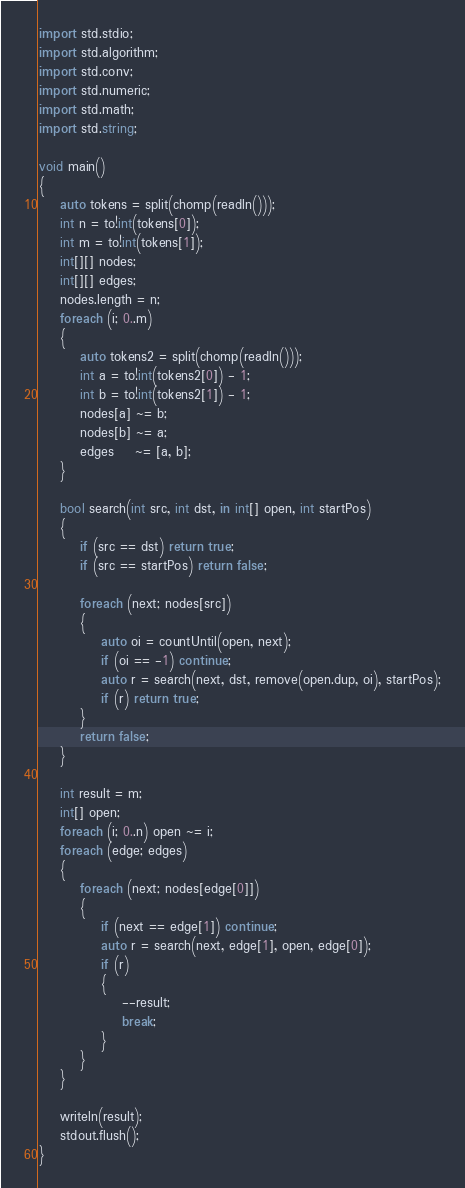<code> <loc_0><loc_0><loc_500><loc_500><_D_>import std.stdio;
import std.algorithm;
import std.conv;
import std.numeric;
import std.math;
import std.string;

void main()
{
	auto tokens = split(chomp(readln()));
	int n = to!int(tokens[0]);
	int m = to!int(tokens[1]);
	int[][] nodes;
	int[][] edges;
	nodes.length = n;
	foreach (i; 0..m)
	{
		auto tokens2 = split(chomp(readln()));
		int a = to!int(tokens2[0]) - 1;
		int b = to!int(tokens2[1]) - 1;
		nodes[a] ~= b;
		nodes[b] ~= a;
		edges    ~= [a, b];
	}

	bool search(int src, int dst, in int[] open, int startPos)
	{
		if (src == dst) return true;
		if (src == startPos) return false;

		foreach (next; nodes[src])
		{
			auto oi = countUntil(open, next);
			if (oi == -1) continue;
			auto r = search(next, dst, remove(open.dup, oi), startPos);
			if (r) return true;
		}
		return false;
	}

	int result = m;
	int[] open;
	foreach (i; 0..n) open ~= i;
	foreach (edge; edges)
	{
		foreach (next; nodes[edge[0]])
		{
			if (next == edge[1]) continue;
			auto r = search(next, edge[1], open, edge[0]);
			if (r)
			{
				--result;
				break;
			}
		}
	}
	
	writeln(result);
	stdout.flush();
}</code> 